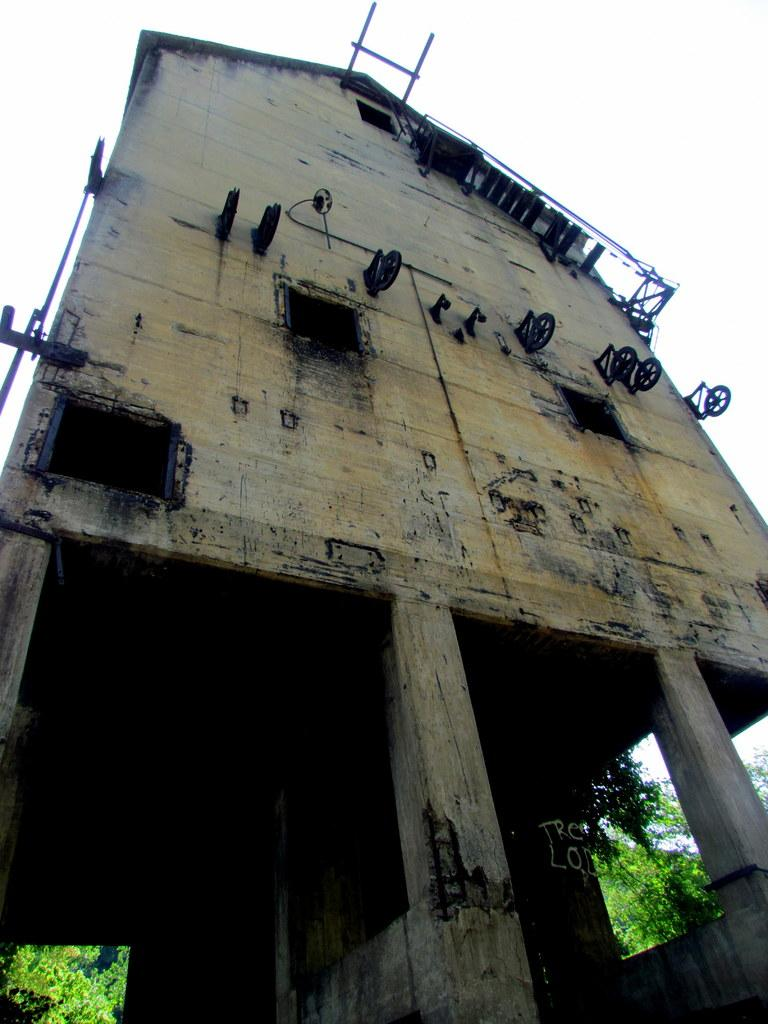What type of structure is present in the image? There is a building in the picture. Can you describe the appearance of the building? The building is old. What other elements can be seen in the image? There are trees in the picture. How would you describe the weather based on the image? The sky is clear, suggesting good weather. What type of parcel is being delivered to the old building in the image? There is no parcel or delivery being depicted in the image. Can you describe the chin of the person standing in front of the old building? There is no person present in the image, so it is impossible to describe their chin. 